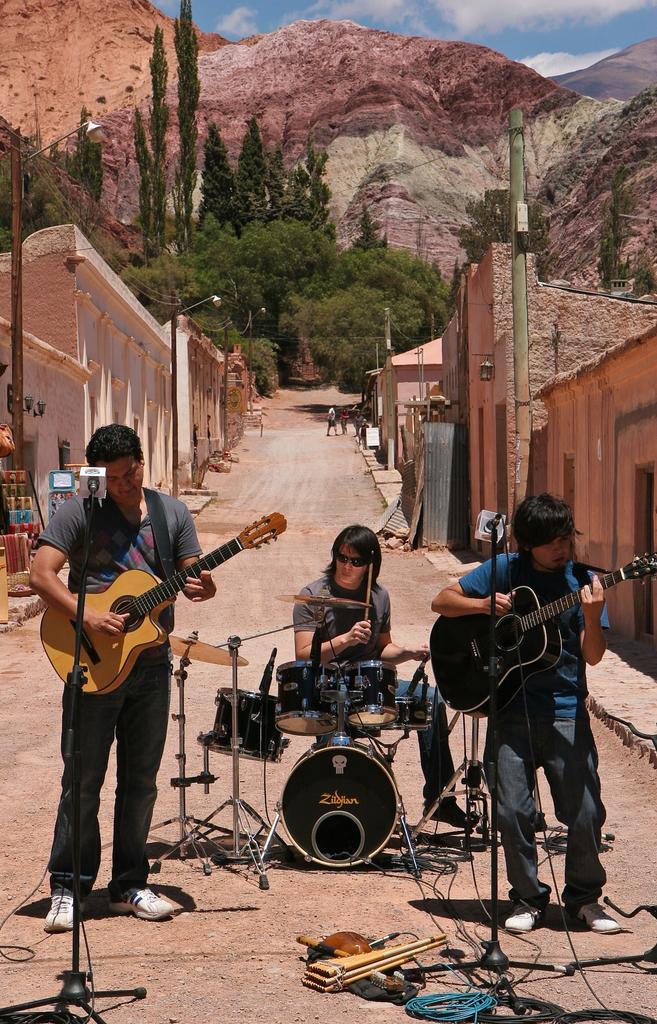How would you summarize this image in a sentence or two? In this picture we can see three persons playing musical instruments such as guitar,drums and they are singing on mic and in the background we can see a path, buildings, pole,light, trees, mountains, sky with clouds. 